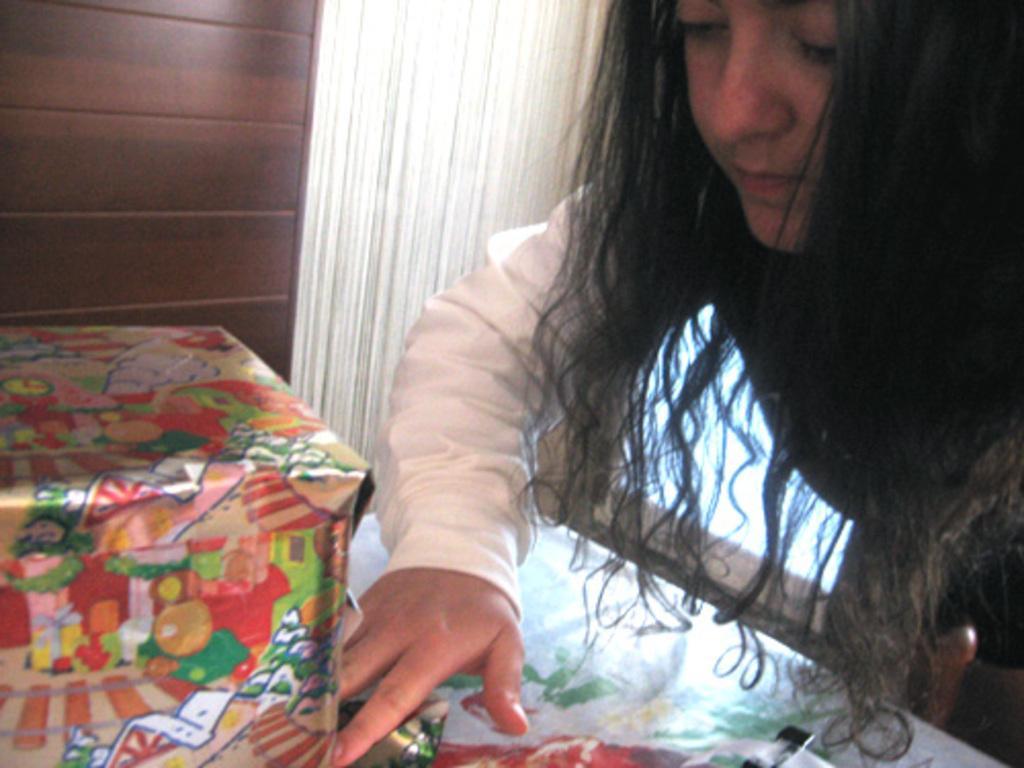Please provide a concise description of this image. This image is taken indoors. At the bottom of the image there is a table with a tablecloth and a gift on it. On the right side of the image there is a girl. In the background there is a wall with a window and a curtain. 